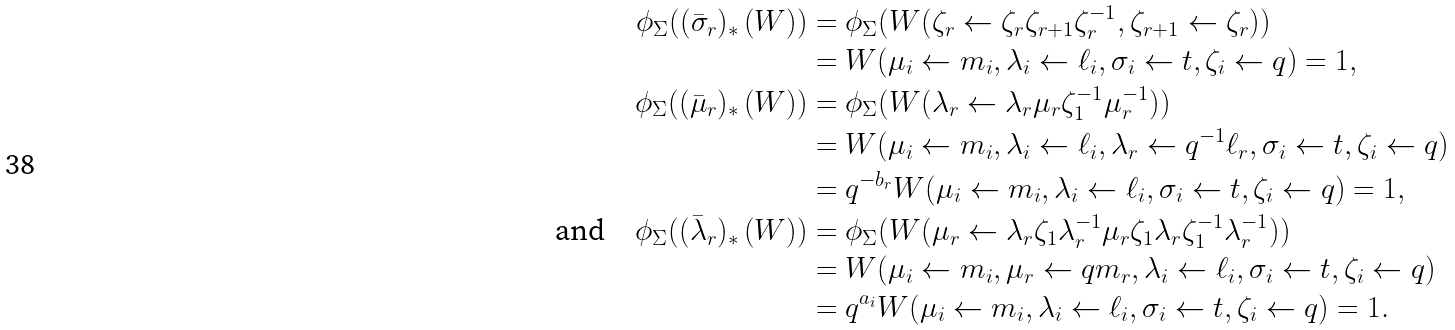<formula> <loc_0><loc_0><loc_500><loc_500>\phi _ { \Sigma } ( ( \bar { \sigma } _ { r } ) _ { * } \left ( W \right ) ) & = \phi _ { \Sigma } ( W ( \zeta _ { r } \leftarrow \zeta _ { r } \zeta _ { r + 1 } \zeta _ { r } ^ { - 1 } , \zeta _ { r + 1 } \leftarrow \zeta _ { r } ) ) \\ & = W ( \mu _ { i } \leftarrow m _ { i } , \lambda _ { i } \leftarrow \ell _ { i } , \sigma _ { i } \leftarrow t , \zeta _ { i } \leftarrow q ) = 1 , \\ \phi _ { \Sigma } ( ( \bar { \mu } _ { r } ) _ { * } \left ( W \right ) ) & = \phi _ { \Sigma } ( W ( \lambda _ { r } \leftarrow \lambda _ { r } \mu _ { r } \zeta _ { 1 } ^ { - 1 } \mu _ { r } ^ { - 1 } ) ) \\ & = W ( \mu _ { i } \leftarrow m _ { i } , \lambda _ { i } \leftarrow \ell _ { i } , \lambda _ { r } \leftarrow q ^ { - 1 } \ell _ { r } , \sigma _ { i } \leftarrow t , \zeta _ { i } \leftarrow q ) \\ & = q ^ { - b _ { r } } W ( \mu _ { i } \leftarrow m _ { i } , \lambda _ { i } \leftarrow \ell _ { i } , \sigma _ { i } \leftarrow t , \zeta _ { i } \leftarrow q ) = 1 , \\ \text {and} \quad \phi _ { \Sigma } ( ( \bar { \lambda } _ { r } ) _ { * } \left ( W \right ) ) & = \phi _ { \Sigma } ( W ( \mu _ { r } \leftarrow \lambda _ { r } \zeta _ { 1 } \lambda _ { r } ^ { - 1 } \mu _ { r } \zeta _ { 1 } \lambda _ { r } \zeta _ { 1 } ^ { - 1 } \lambda _ { r } ^ { - 1 } ) ) \\ & = W ( \mu _ { i } \leftarrow m _ { i } , \mu _ { r } \leftarrow q m _ { r } , \lambda _ { i } \leftarrow \ell _ { i } , \sigma _ { i } \leftarrow t , \zeta _ { i } \leftarrow q ) \\ & = q ^ { a _ { i } } W ( \mu _ { i } \leftarrow m _ { i } , \lambda _ { i } \leftarrow \ell _ { i } , \sigma _ { i } \leftarrow t , \zeta _ { i } \leftarrow q ) = 1 .</formula> 